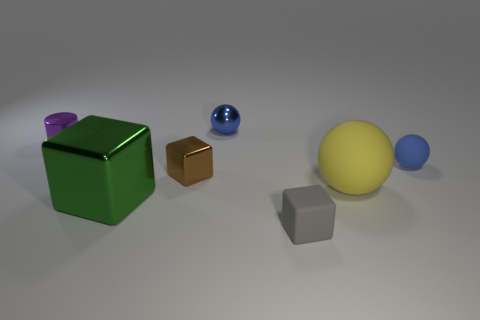Subtract all large spheres. How many spheres are left? 2 Add 3 cylinders. How many objects exist? 10 Subtract all blue spheres. How many spheres are left? 1 Subtract 3 blocks. How many blocks are left? 0 Subtract all yellow spheres. Subtract all cyan cylinders. How many spheres are left? 2 Subtract all gray balls. How many green blocks are left? 1 Subtract all shiny cubes. Subtract all yellow rubber cylinders. How many objects are left? 5 Add 3 big matte things. How many big matte things are left? 4 Add 6 blue metal spheres. How many blue metal spheres exist? 7 Subtract 1 brown cubes. How many objects are left? 6 